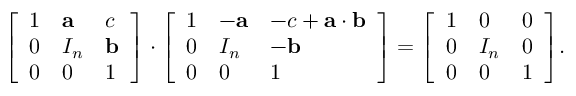<formula> <loc_0><loc_0><loc_500><loc_500>{ \left [ \begin{array} { l l l } { 1 } & { a } & { c } \\ { 0 } & { I _ { n } } & { b } \\ { 0 } & { 0 } & { 1 } \end{array} \right ] } \cdot { \left [ \begin{array} { l l l } { 1 } & { - a } & { - c + a \cdot b } \\ { 0 } & { I _ { n } } & { - b } \\ { 0 } & { 0 } & { 1 } \end{array} \right ] } = { \left [ \begin{array} { l l l } { 1 } & { 0 } & { 0 } \\ { 0 } & { I _ { n } } & { 0 } \\ { 0 } & { 0 } & { 1 } \end{array} \right ] } .</formula> 